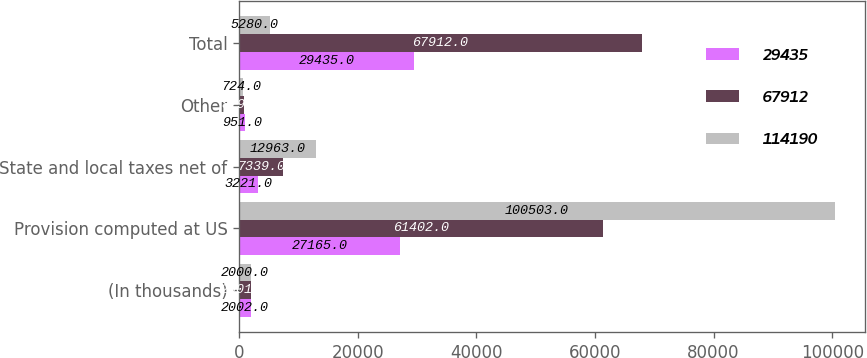Convert chart. <chart><loc_0><loc_0><loc_500><loc_500><stacked_bar_chart><ecel><fcel>(In thousands)<fcel>Provision computed at US<fcel>State and local taxes net of<fcel>Other<fcel>Total<nl><fcel>29435<fcel>2002<fcel>27165<fcel>3221<fcel>951<fcel>29435<nl><fcel>67912<fcel>2001<fcel>61402<fcel>7339<fcel>829<fcel>67912<nl><fcel>114190<fcel>2000<fcel>100503<fcel>12963<fcel>724<fcel>5280<nl></chart> 